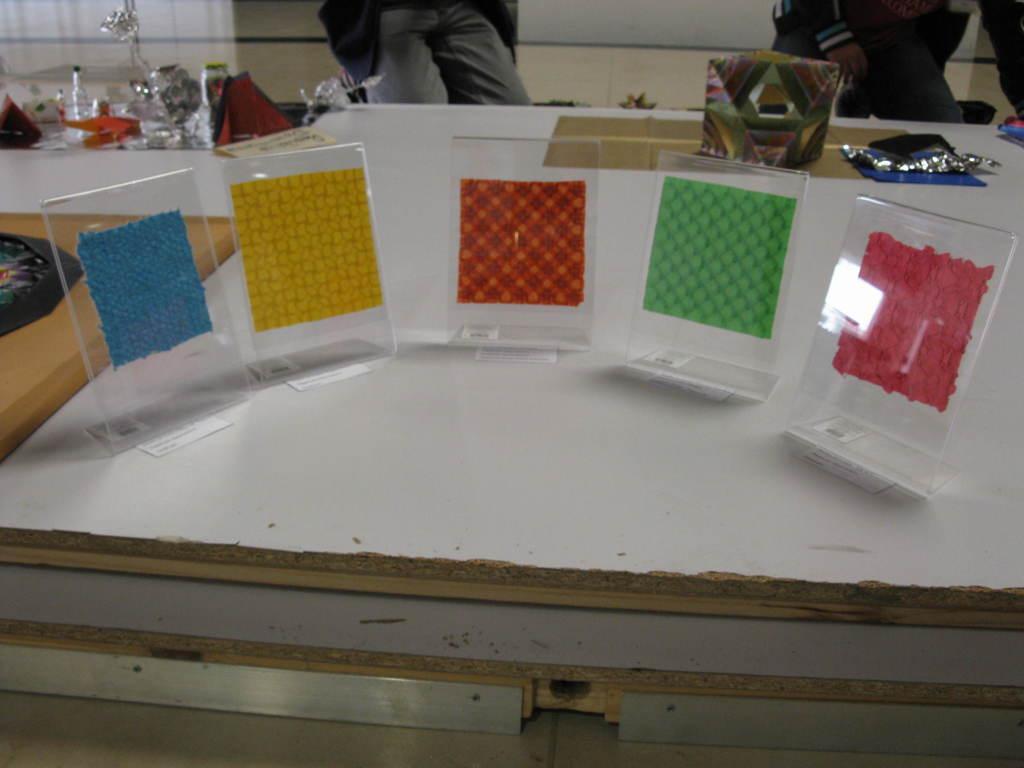How would you summarize this image in a sentence or two? In the foreground of this picture we can see the wooden boards on the top of which papers, box and some objects which seems to be the show pieces and some other objects are placed. In the background we can see the floor and the wall and we can see the two people kneeling on the ground. 